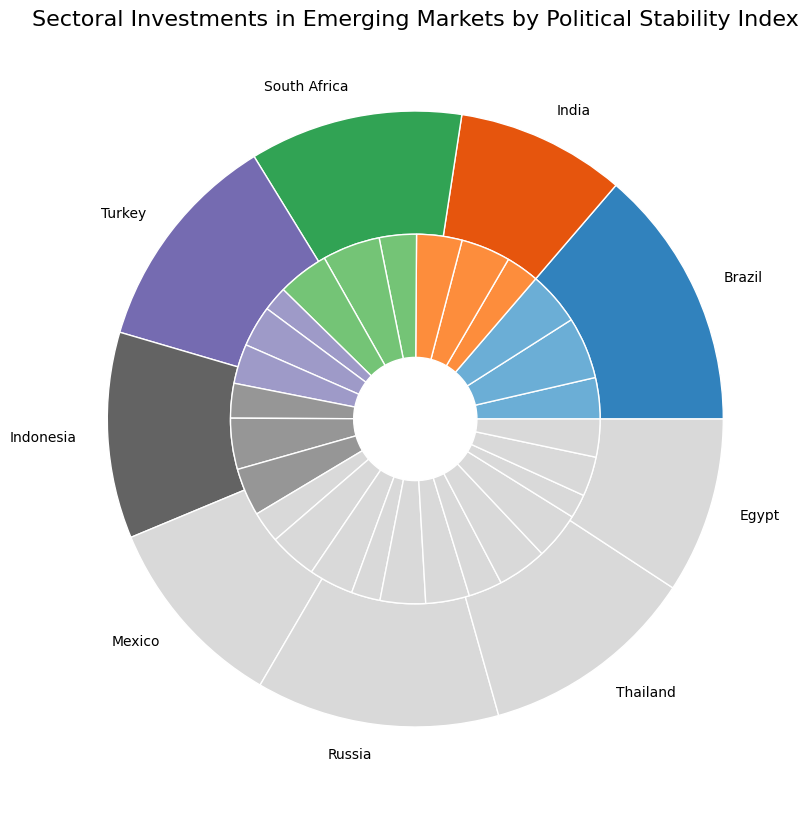Which country has the highest investment in the Services sector? By looking at the smaller, inner pie chart and identifying the largest segment labeled "Services," we can determine that South Africa has the highest investment in the Services sector.
Answer: South Africa What is the total investment in Manufacturing sectors across all countries? First, note the investment amounts for Manufacturing in each country: Brazil (750), India (600), South Africa (700), Turkey (500), Indonesia (620), Mexico (580), Russia (550), Thailand (600), Egypt (480). Adding these figures: 750 + 600 + 700 + 500 + 620 + 580 + 550 + 600 + 480 = 5380.
Answer: 5380 Which country has the lowest overall investment? From the outer pie chart, the smallest slice represents the country with the lowest total investment, which is Egypt.
Answer: Egypt Between Brazil and Turkey, which one has a higher total investment? Compare the sizes of the outer slices for Brazil and Turkey. Brazil's slice is larger than Turkey's, indicating a higher total investment.
Answer: Brazil How does the investment in Agriculture compare between Mexico and Indonesia? Check the inner pie chart slices labeled "Agriculture" for both Mexico and Indonesia. Compare their sizes visually, noting that Indonesia's slice is larger.
Answer: Indonesia has higher investment What is the difference in investment in Agriculture between Brazil and India? Brazil's investment in Agriculture is 500 million, and India's is 400 million. The difference is 500 - 400 = 100.
Answer: 100 Which sector has the smallest investment in Thailand? In Thailand, the smallest inner pie chart segment is for "Agriculture," indicating the smallest investment.
Answer: Agriculture How does the investment in the Manufacturing sector in South Africa compare to the entire investment in Brazil? South Africa's Manufacturing investment is 700 million. The total investment in Brazil is 500 (Agri) + 750 (Manu) + 650 (Services). Comparing both, South Africa's 700 is less than Brazil's total of 1900 million.
Answer: Lower What is the average investment in the Services sector across all countries? Sum the investments for Services: 650 (Brazil) + 550 (India) + 620 (South Africa) + 480 (Turkey) + 580 (Indonesia) + 540 (Mexico) + 530 (Russia) + 570 (Thailand) + 460 (Egypt) = 4980. Divide by the number of countries (9): 4980 / 9 ≈ 553.33.
Answer: 553.33 Which country's investment distribution among sectors is the most balanced? Look for countries where the inner pie chart slices for each sector are relatively equal in size. Brazil shows a well-balanced distribution among Agriculture, Manufacturing, and Services.
Answer: Brazil 